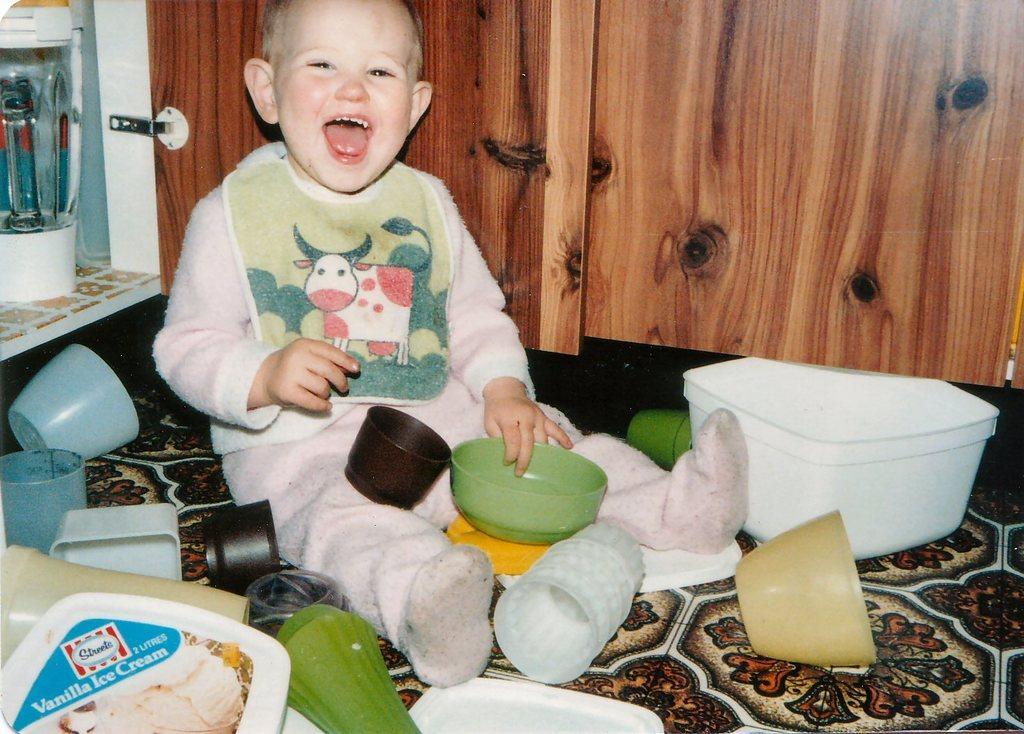In one or two sentences, can you explain what this image depicts? In this picture there is a boy who is sitting on the carpet. On the bottom we can see glass, bowls, cups, plastic plate and other objects. On the right we can see wooden wall. On the top left we can see grinder. 